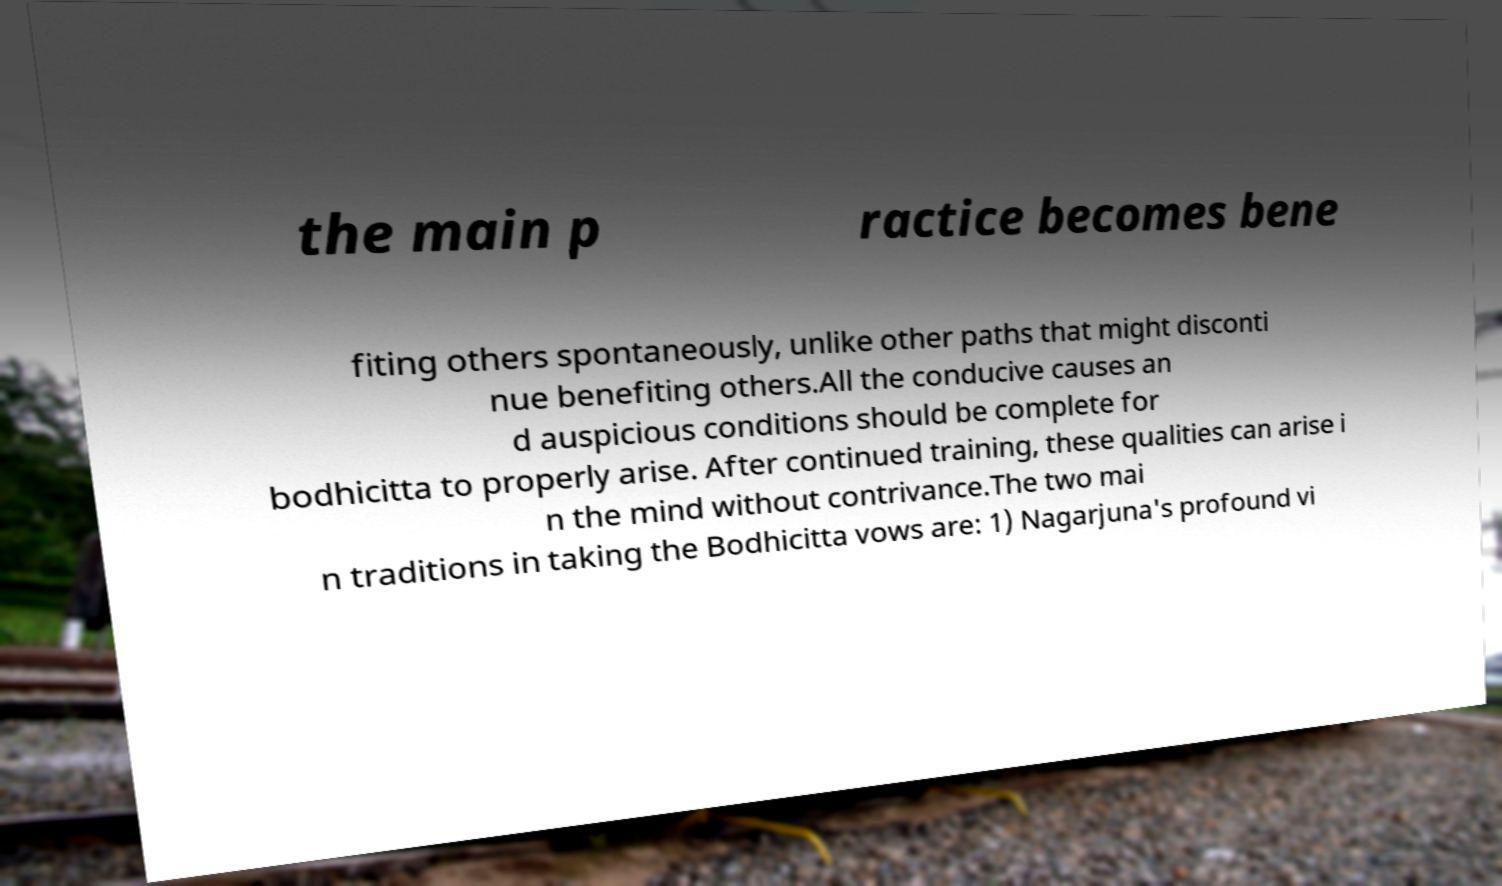Can you read and provide the text displayed in the image?This photo seems to have some interesting text. Can you extract and type it out for me? the main p ractice becomes bene fiting others spontaneously, unlike other paths that might disconti nue benefiting others.All the conducive causes an d auspicious conditions should be complete for bodhicitta to properly arise. After continued training, these qualities can arise i n the mind without contrivance.The two mai n traditions in taking the Bodhicitta vows are: 1) Nagarjuna's profound vi 